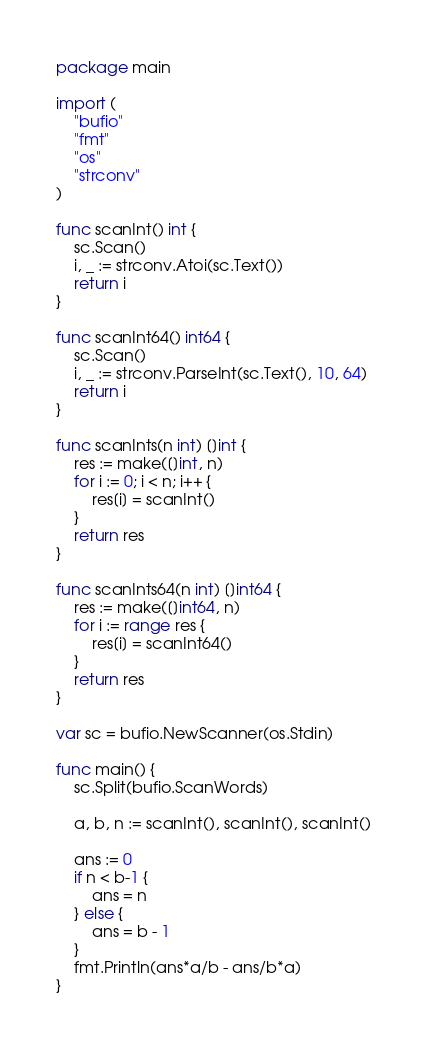Convert code to text. <code><loc_0><loc_0><loc_500><loc_500><_Go_>package main

import (
	"bufio"
	"fmt"
	"os"
	"strconv"
)

func scanInt() int {
	sc.Scan()
	i, _ := strconv.Atoi(sc.Text())
	return i
}

func scanInt64() int64 {
	sc.Scan()
	i, _ := strconv.ParseInt(sc.Text(), 10, 64)
	return i
}

func scanInts(n int) []int {
	res := make([]int, n)
	for i := 0; i < n; i++ {
		res[i] = scanInt()
	}
	return res
}

func scanInts64(n int) []int64 {
	res := make([]int64, n)
	for i := range res {
		res[i] = scanInt64()
	}
	return res
}

var sc = bufio.NewScanner(os.Stdin)

func main() {
	sc.Split(bufio.ScanWords)

	a, b, n := scanInt(), scanInt(), scanInt()

	ans := 0
	if n < b-1 {
		ans = n
	} else {
		ans = b - 1
	}
	fmt.Println(ans*a/b - ans/b*a)
}
</code> 